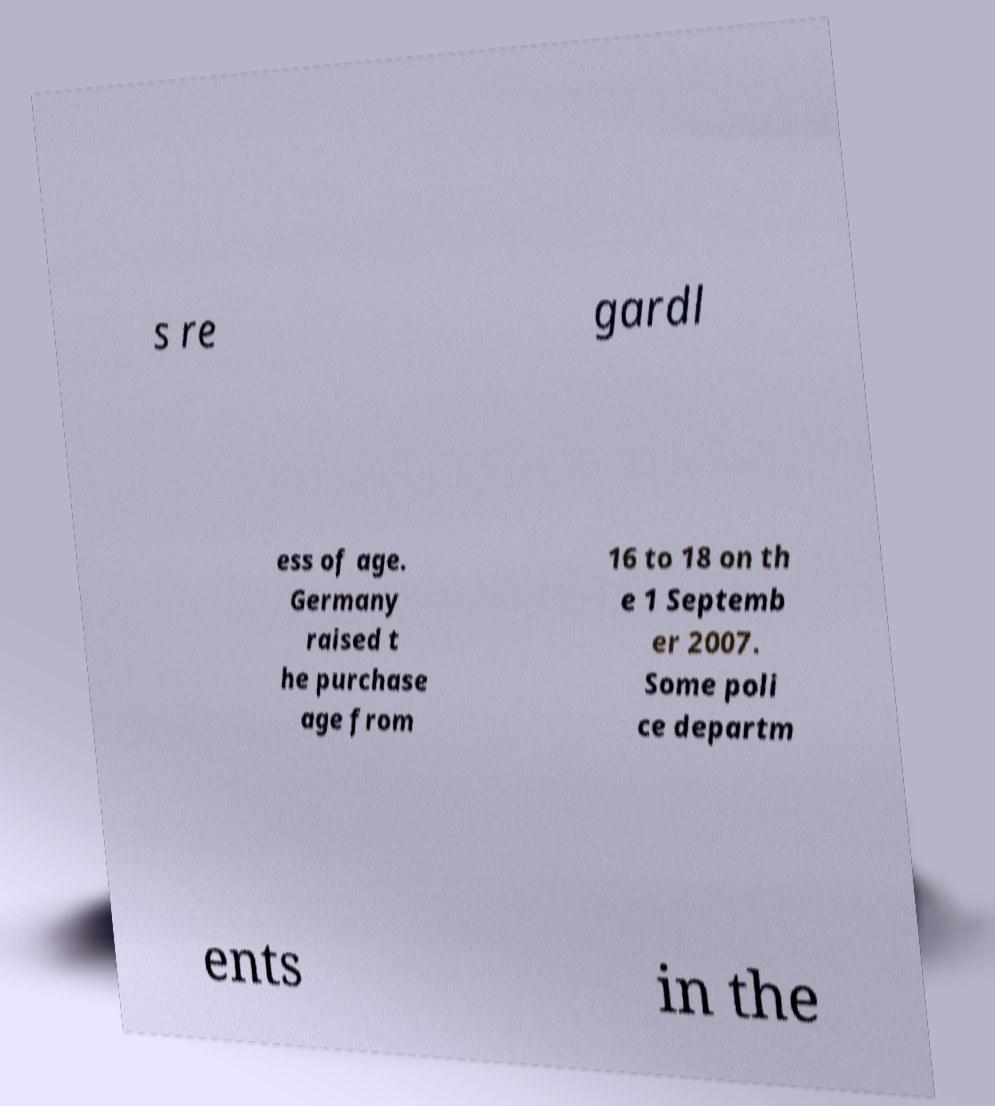What messages or text are displayed in this image? I need them in a readable, typed format. s re gardl ess of age. Germany raised t he purchase age from 16 to 18 on th e 1 Septemb er 2007. Some poli ce departm ents in the 